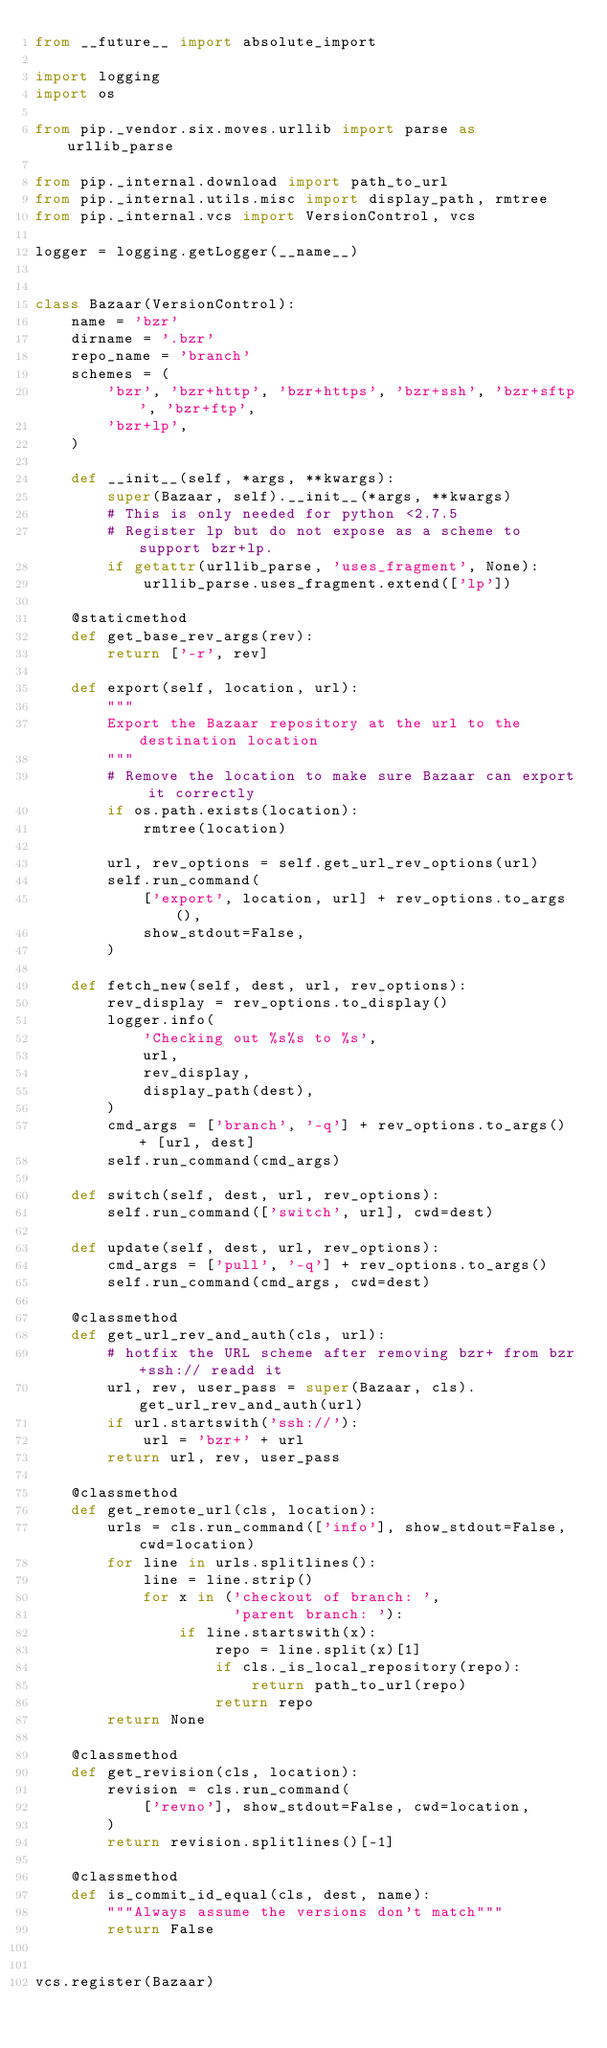Convert code to text. <code><loc_0><loc_0><loc_500><loc_500><_Python_>from __future__ import absolute_import

import logging
import os

from pip._vendor.six.moves.urllib import parse as urllib_parse

from pip._internal.download import path_to_url
from pip._internal.utils.misc import display_path, rmtree
from pip._internal.vcs import VersionControl, vcs

logger = logging.getLogger(__name__)


class Bazaar(VersionControl):
    name = 'bzr'
    dirname = '.bzr'
    repo_name = 'branch'
    schemes = (
        'bzr', 'bzr+http', 'bzr+https', 'bzr+ssh', 'bzr+sftp', 'bzr+ftp',
        'bzr+lp',
    )

    def __init__(self, *args, **kwargs):
        super(Bazaar, self).__init__(*args, **kwargs)
        # This is only needed for python <2.7.5
        # Register lp but do not expose as a scheme to support bzr+lp.
        if getattr(urllib_parse, 'uses_fragment', None):
            urllib_parse.uses_fragment.extend(['lp'])

    @staticmethod
    def get_base_rev_args(rev):
        return ['-r', rev]

    def export(self, location, url):
        """
        Export the Bazaar repository at the url to the destination location
        """
        # Remove the location to make sure Bazaar can export it correctly
        if os.path.exists(location):
            rmtree(location)

        url, rev_options = self.get_url_rev_options(url)
        self.run_command(
            ['export', location, url] + rev_options.to_args(),
            show_stdout=False,
        )

    def fetch_new(self, dest, url, rev_options):
        rev_display = rev_options.to_display()
        logger.info(
            'Checking out %s%s to %s',
            url,
            rev_display,
            display_path(dest),
        )
        cmd_args = ['branch', '-q'] + rev_options.to_args() + [url, dest]
        self.run_command(cmd_args)

    def switch(self, dest, url, rev_options):
        self.run_command(['switch', url], cwd=dest)

    def update(self, dest, url, rev_options):
        cmd_args = ['pull', '-q'] + rev_options.to_args()
        self.run_command(cmd_args, cwd=dest)

    @classmethod
    def get_url_rev_and_auth(cls, url):
        # hotfix the URL scheme after removing bzr+ from bzr+ssh:// readd it
        url, rev, user_pass = super(Bazaar, cls).get_url_rev_and_auth(url)
        if url.startswith('ssh://'):
            url = 'bzr+' + url
        return url, rev, user_pass

    @classmethod
    def get_remote_url(cls, location):
        urls = cls.run_command(['info'], show_stdout=False, cwd=location)
        for line in urls.splitlines():
            line = line.strip()
            for x in ('checkout of branch: ',
                      'parent branch: '):
                if line.startswith(x):
                    repo = line.split(x)[1]
                    if cls._is_local_repository(repo):
                        return path_to_url(repo)
                    return repo
        return None

    @classmethod
    def get_revision(cls, location):
        revision = cls.run_command(
            ['revno'], show_stdout=False, cwd=location,
        )
        return revision.splitlines()[-1]

    @classmethod
    def is_commit_id_equal(cls, dest, name):
        """Always assume the versions don't match"""
        return False


vcs.register(Bazaar)
</code> 